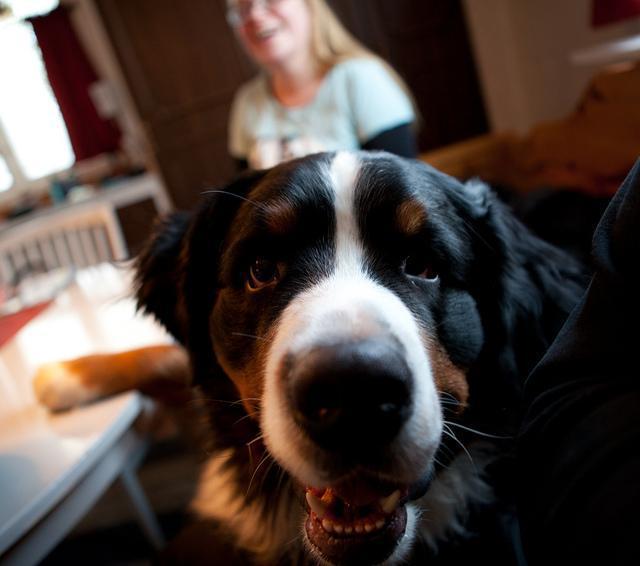How many people are there?
Give a very brief answer. 2. 